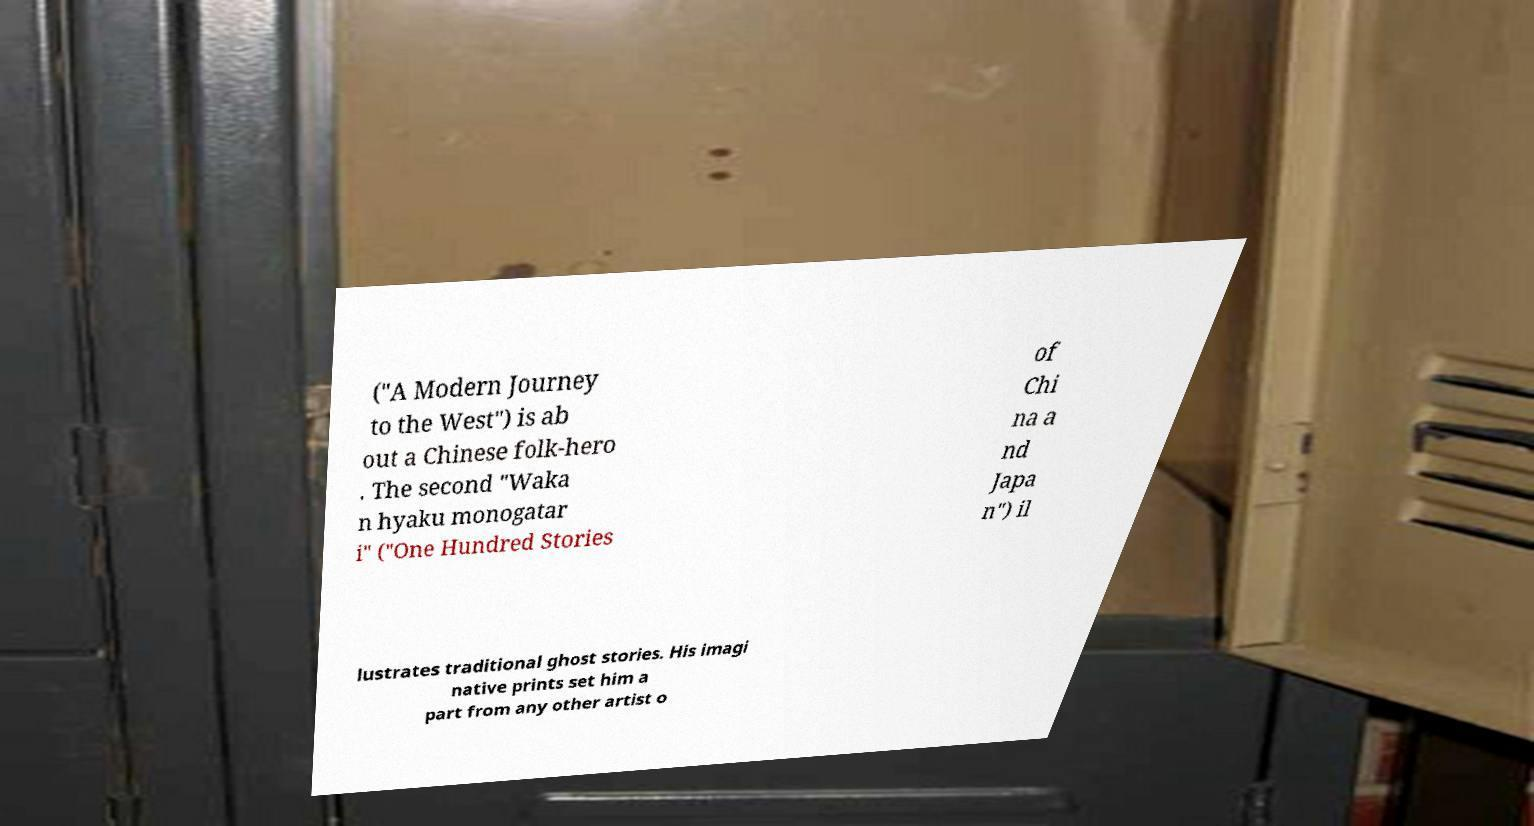Could you assist in decoding the text presented in this image and type it out clearly? ("A Modern Journey to the West") is ab out a Chinese folk-hero . The second "Waka n hyaku monogatar i" ("One Hundred Stories of Chi na a nd Japa n") il lustrates traditional ghost stories. His imagi native prints set him a part from any other artist o 